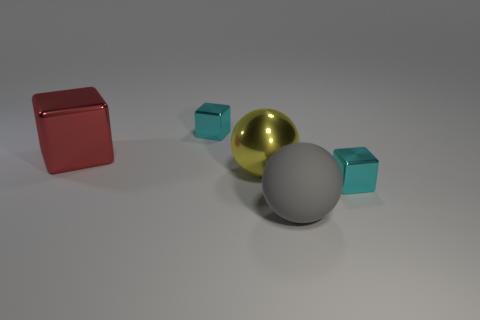Does the big gray sphere have the same material as the object that is on the right side of the big matte sphere?
Offer a terse response. No. The tiny cyan object in front of the cyan object that is behind the yellow object is what shape?
Your answer should be very brief. Cube. There is a object that is both behind the matte object and in front of the large yellow shiny ball; what shape is it?
Give a very brief answer. Cube. How many things are big red shiny objects or cyan cubes that are right of the big gray object?
Keep it short and to the point. 2. There is a gray object that is the same shape as the yellow metallic thing; what material is it?
Offer a terse response. Rubber. Is there any other thing that is the same material as the large gray thing?
Your answer should be very brief. No. What is the block that is both on the right side of the red cube and left of the yellow metal thing made of?
Your answer should be compact. Metal. How many cyan things are the same shape as the gray thing?
Ensure brevity in your answer.  0. The shiny cube that is in front of the big object that is left of the large yellow ball is what color?
Give a very brief answer. Cyan. Are there an equal number of large metal balls that are in front of the big gray rubber sphere and small blocks?
Your answer should be very brief. No. 